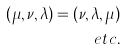<formula> <loc_0><loc_0><loc_500><loc_500>( \mu , \nu , \lambda ) = ( \nu , \lambda , \mu ) \\ e t c .</formula> 